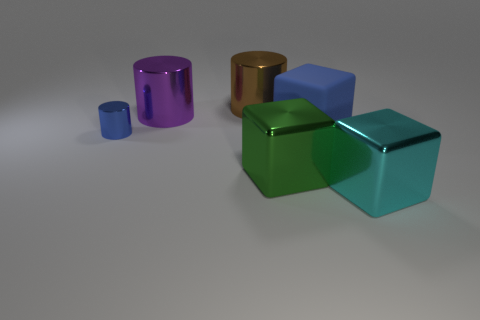Add 1 tiny blue matte objects. How many objects exist? 7 Subtract 0 gray balls. How many objects are left? 6 Subtract all purple things. Subtract all big purple cylinders. How many objects are left? 4 Add 4 cubes. How many cubes are left? 7 Add 6 big brown things. How many big brown things exist? 7 